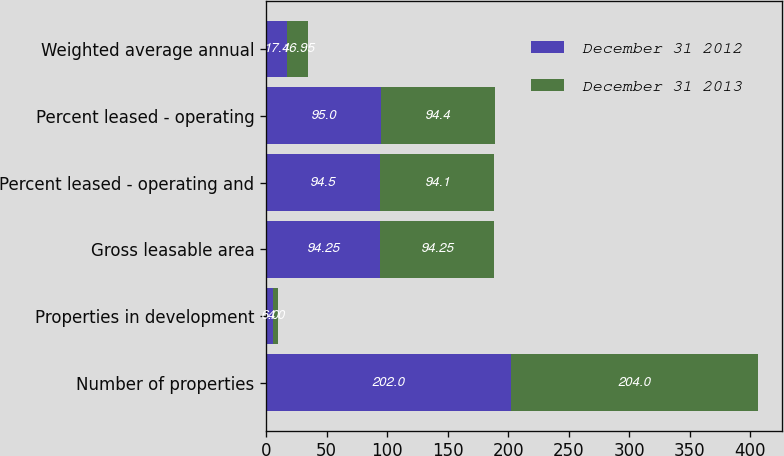<chart> <loc_0><loc_0><loc_500><loc_500><stacked_bar_chart><ecel><fcel>Number of properties<fcel>Properties in development<fcel>Gross leasable area<fcel>Percent leased - operating and<fcel>Percent leased - operating<fcel>Weighted average annual<nl><fcel>December 31 2012<fcel>202<fcel>6<fcel>94.25<fcel>94.5<fcel>95<fcel>17.4<nl><fcel>December 31 2013<fcel>204<fcel>4<fcel>94.25<fcel>94.1<fcel>94.4<fcel>16.95<nl></chart> 